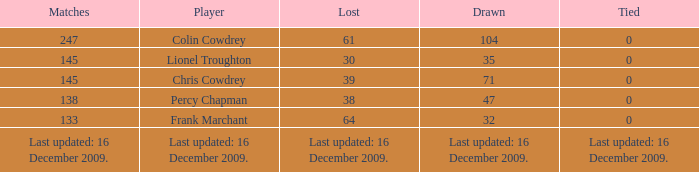Tell me the lost with tie of 0 and drawn of 47 38.0. 